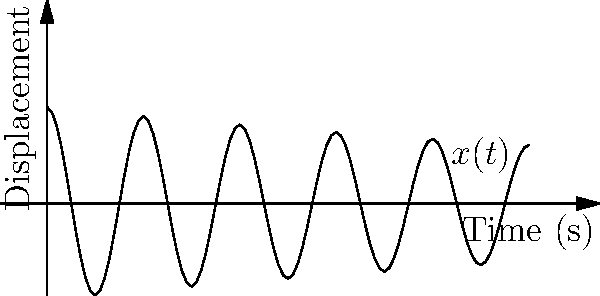Consider a spring-mass system with damping, described by the differential equation:

$$m\frac{d^2x}{dt^2} + c\frac{dx}{dt} + kx = 0$$

where $m = 1$ kg, $c = 0.2$ N⋅s/m, and $k = 16$ N/m. The displacement $x(t)$ is shown in the graph above. Determine the natural frequency $\omega_n$ of this system in rad/s. To find the natural frequency $\omega_n$, we'll follow these steps:

1) The natural frequency of a spring-mass system is given by:

   $$\omega_n = \sqrt{\frac{k}{m}}$$

2) We're given:
   $m = 1$ kg
   $k = 16$ N/m

3) Substituting these values:

   $$\omega_n = \sqrt{\frac{16}{1}} = \sqrt{16} = 4\text{ rad/s}$$

4) We can verify this result using the graph. The natural frequency is related to the period $T$ of oscillation:

   $$\omega_n = \frac{2\pi}{T}$$

5) From the graph, we can see that one complete oscillation takes about 1.57 seconds (the time between two peaks).

6) This gives us:

   $$\omega_n = \frac{2\pi}{1.57} \approx 4\text{ rad/s}$$

   Which confirms our calculation.

Note: The damping coefficient $c$ doesn't affect the natural frequency, but it does affect the decay rate of the oscillations, as seen in the exponential envelope of the graph.
Answer: $4\text{ rad/s}$ 